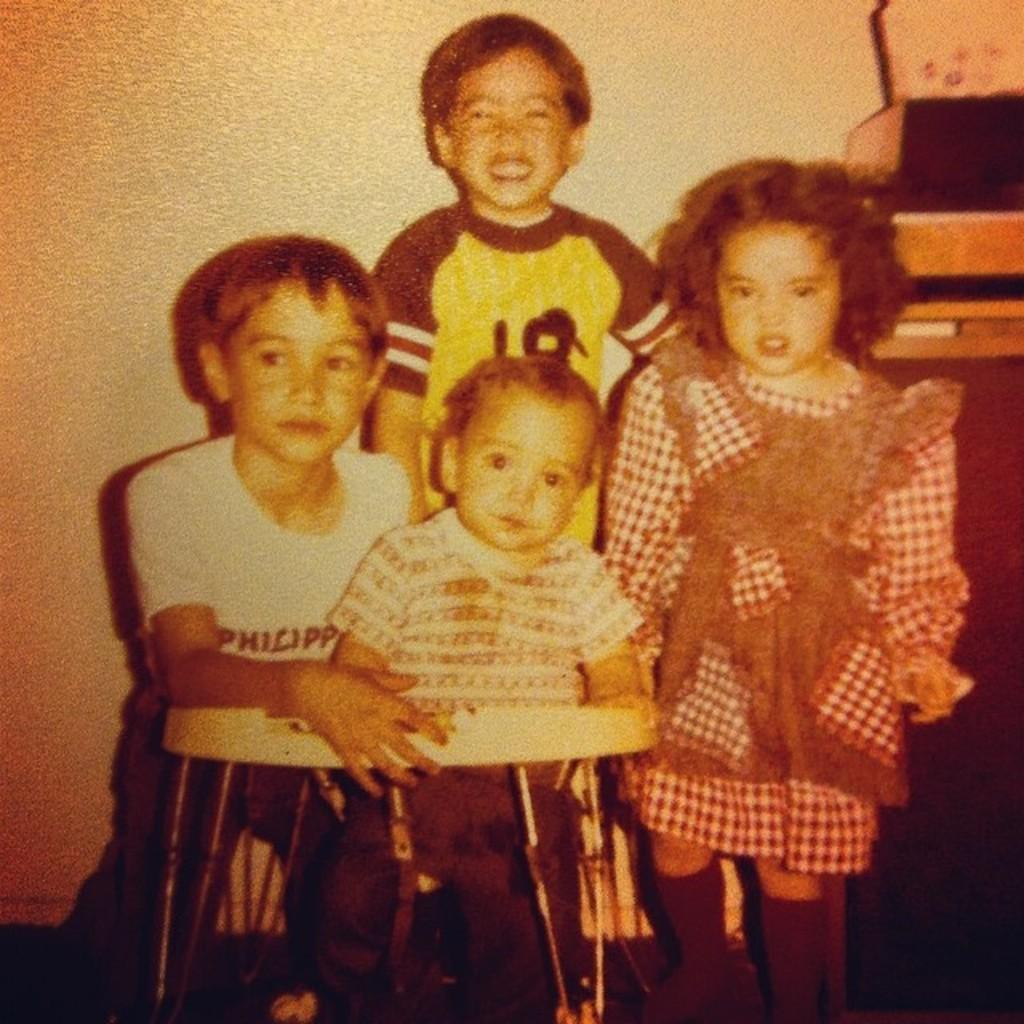How many children are present in the image? There are four kids in the image. What is the object at the bottom of the image? There is a baby walker at the bottom of the image. What can be seen in the background of the image? There is a wall in the background of the image. What is located on the right side of the image? There is an object on the right side of the image. What type of meal is being prepared in the image? There is no indication of a meal being prepared in the image. Can you tell me how many buttons are on the baby walker? The image does not show any buttons on the baby walker. Is there a donkey present in the image? No, there is no donkey present in the image. 